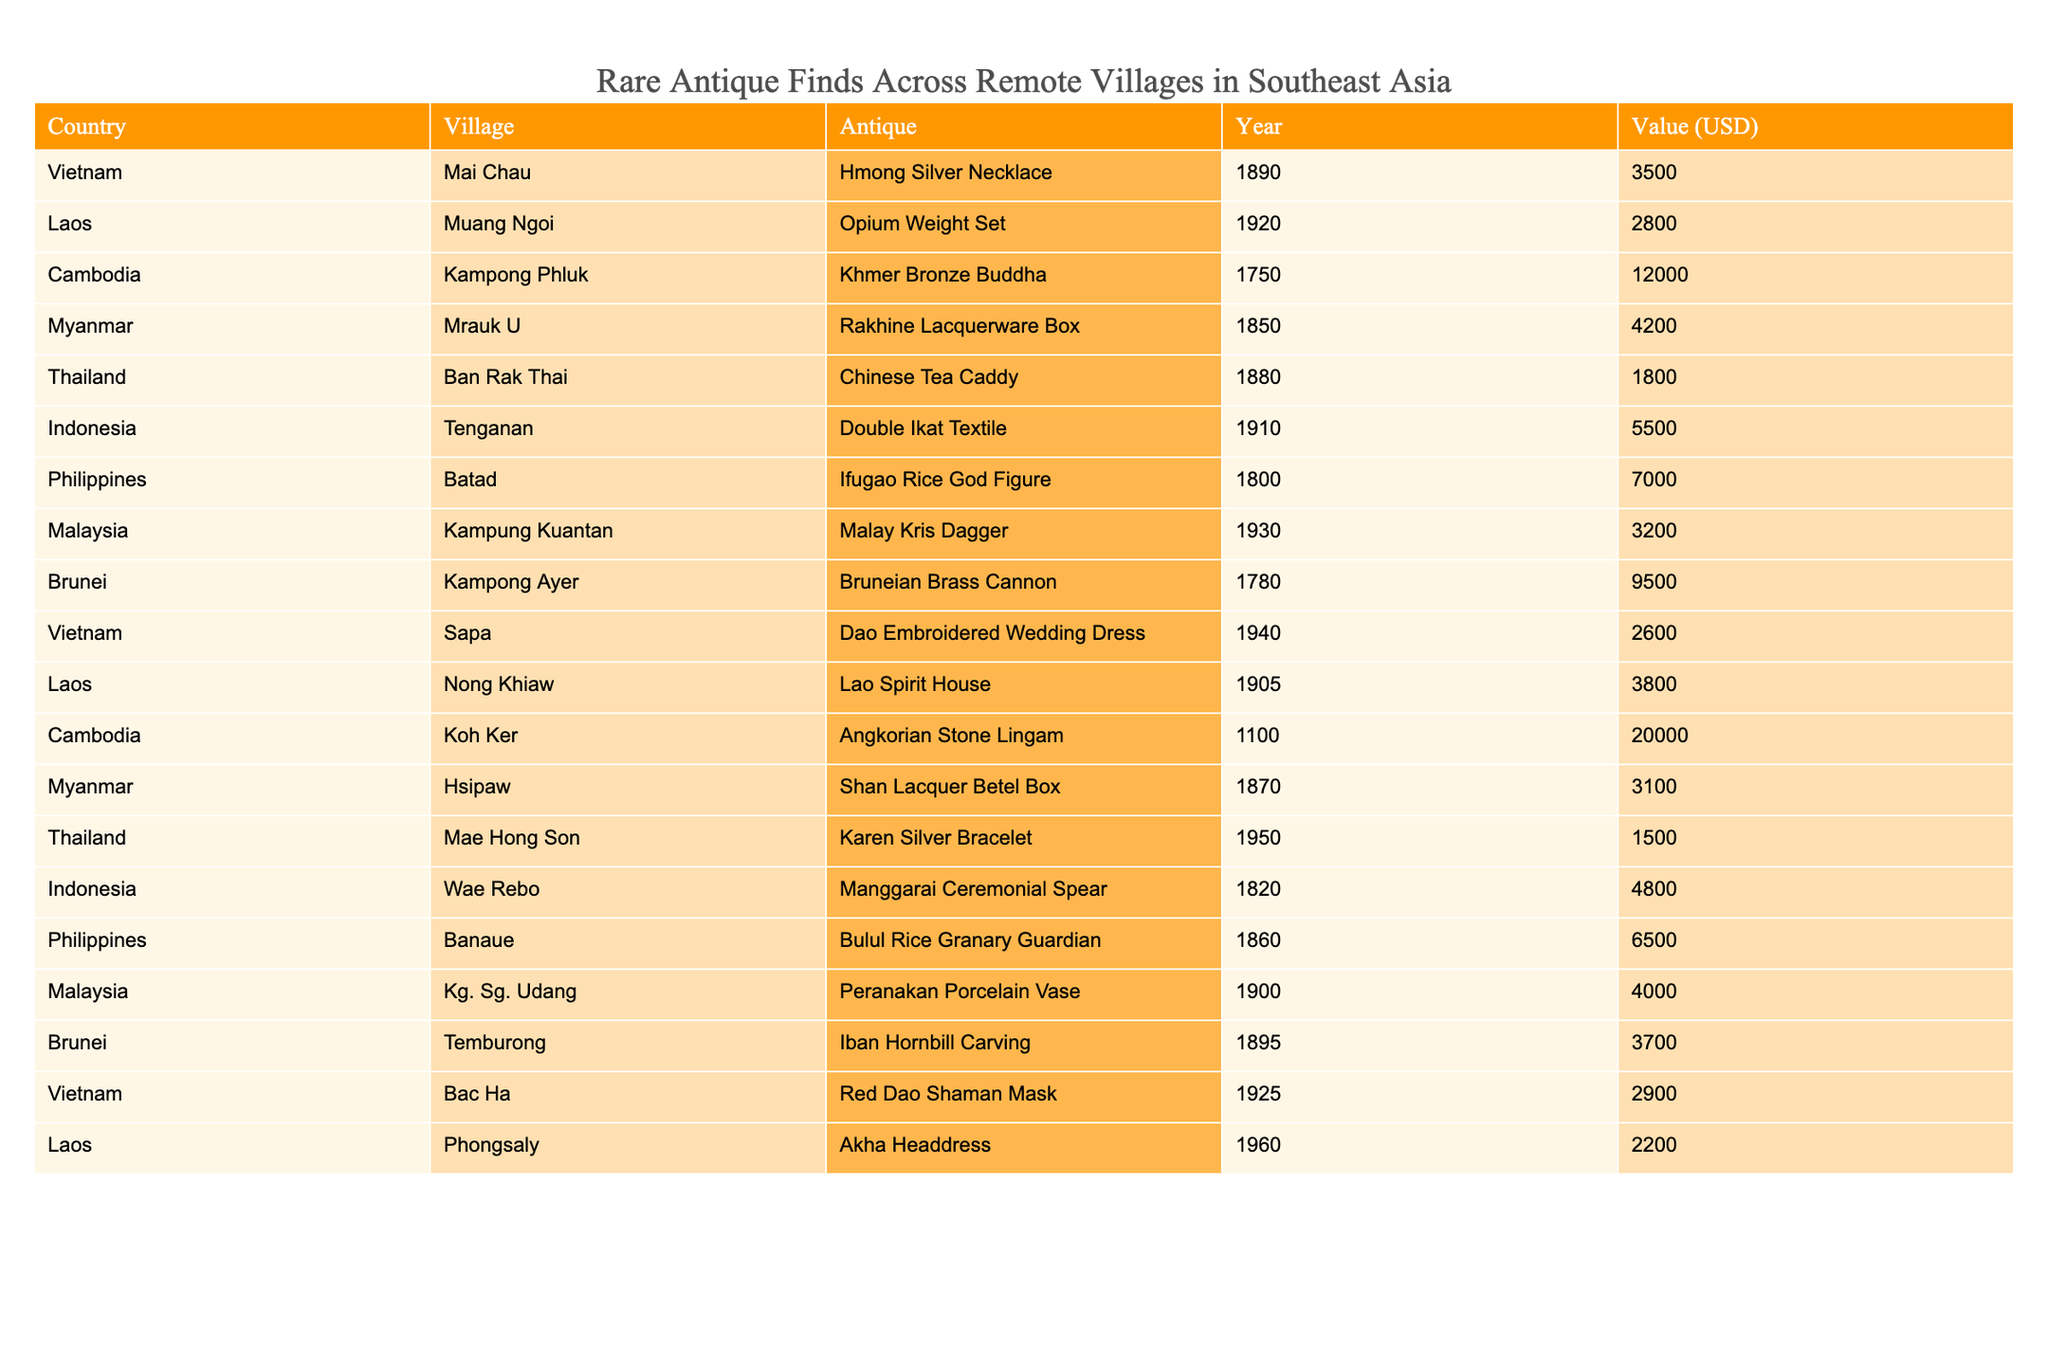What is the value of the Khmer Bronze Buddha from Cambodia? The table lists the Khmer Bronze Buddha found in Kampong Phluk, Cambodia, with a value of 12000 USD.
Answer: 12000 USD Which antique has the highest value? By examining the values listed in the table, the Angkorian Stone Lingam from Koh Ker, Cambodia, has the highest value of 20000 USD.
Answer: 20000 USD How many antiques are from Vietnam? The table shows that there are three antiques from Vietnam: Hmong Silver Necklace, Dao Embroidered Wedding Dress, and Red Dao Shaman Mask.
Answer: 3 What is the average value of antiques from Laos? The antiques from Laos are: Opium Weight Set (2800 USD), Lao Spirit House (3800 USD), and Akha Headdress (2200 USD). The sum is 2800 + 3800 + 2200 = 8800 USD, divided by 3 gives an average of 2933.33 USD.
Answer: 2933.33 USD Is the Chinese Tea Caddy from Thailand valued over 2000 USD? The table lists the Chinese Tea Caddy from Ban Rak Thai, Thailand, with a value of 1800 USD, which is not over 2000 USD.
Answer: No What is the total value of antiques from Indonesia and Malaysia combined? From Indonesia, we have: Double Ikat Textile (5500 USD) and Manggarai Ceremonial Spear (4800 USD). From Malaysia, we have: Malay Kris Dagger (3200 USD) and Peranakan Porcelain Vase (4000 USD). Their total value is 5500 + 4800 + 3200 + 4000 = 17500 USD.
Answer: 17500 USD Which country has the fewest antique finds listed in the table? By reviewing the countries, Vietnam has three antiques, Laos has three, Cambodia has three, Myanmar has three, Thailand has two, Indonesia has two, Philippines has two, Malaysia has two, and Brunei has two. The country with the fewest listed definitely is Thailand with only two items.
Answer: Thailand Is there an antique from Brunei that is valued over 5000 USD? The Bruneian Brass Cannon listed has a value of 9500 USD, which is indeed over 5000 USD.
Answer: Yes What are the values of the antiques from the Philippines, and how do they compare to those from Vietnam? The antiques from the Philippines are: Ifugao Rice God Figure (7000 USD) and Bulul Rice Granary Guardian (6500 USD), totaling 13500 USD. The antiques from Vietnam: Hmong Silver Necklace (3500 USD), Dao Embroidered Wedding Dress (2600 USD), and Red Dao Shaman Mask (2900 USD), totaling 9000 USD. Therefore, antiques from the Philippines are valued higher than those from Vietnam.
Answer: Higher Which antique was created in 1960, and what is its value? The table shows that the Akha Headdress from Laos was created in 1960, valued at 2200 USD.
Answer: 2200 USD 